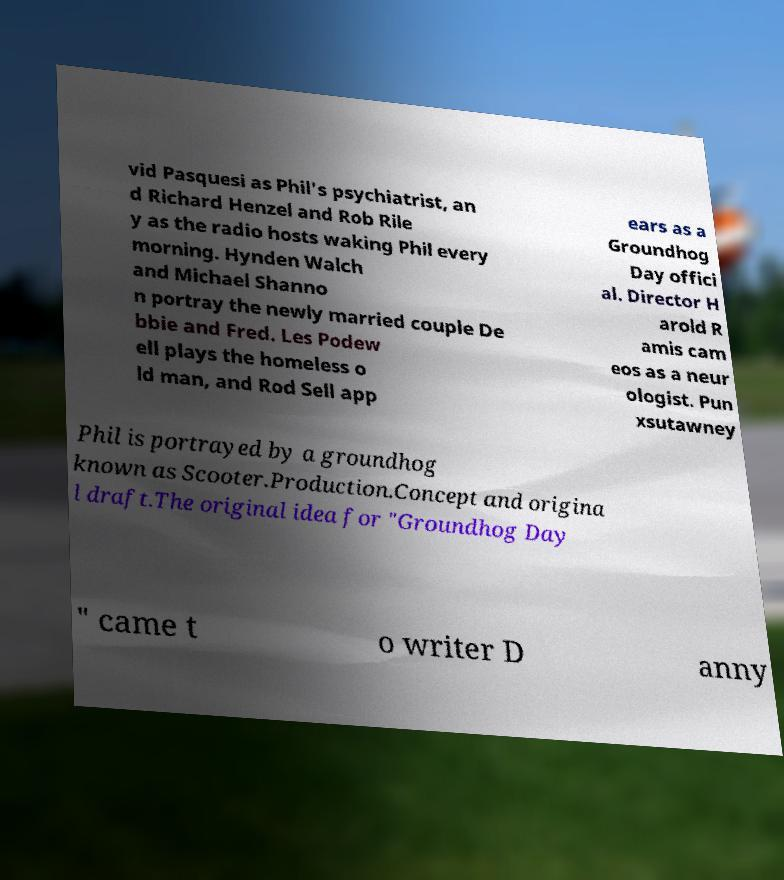For documentation purposes, I need the text within this image transcribed. Could you provide that? vid Pasquesi as Phil's psychiatrist, an d Richard Henzel and Rob Rile y as the radio hosts waking Phil every morning. Hynden Walch and Michael Shanno n portray the newly married couple De bbie and Fred. Les Podew ell plays the homeless o ld man, and Rod Sell app ears as a Groundhog Day offici al. Director H arold R amis cam eos as a neur ologist. Pun xsutawney Phil is portrayed by a groundhog known as Scooter.Production.Concept and origina l draft.The original idea for "Groundhog Day " came t o writer D anny 